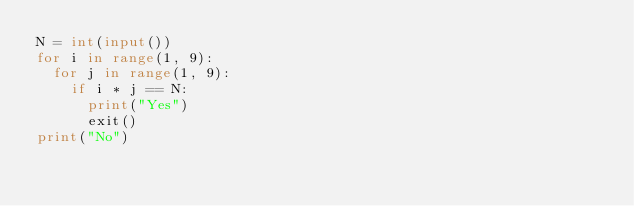<code> <loc_0><loc_0><loc_500><loc_500><_Python_>N = int(input())
for i in range(1, 9):
  for j in range(1, 9):
    if i * j == N:
      print("Yes")
      exit()
print("No")</code> 